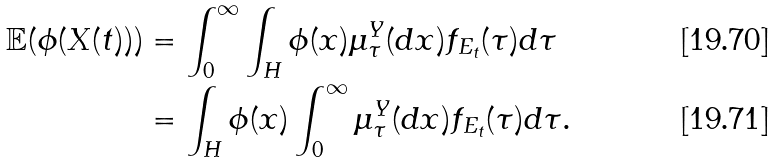Convert formula to latex. <formula><loc_0><loc_0><loc_500><loc_500>\mathbb { E } ( \phi ( X ( t ) ) ) & = \int _ { 0 } ^ { \infty } \int _ { H } \phi ( x ) \mu _ { \tau } ^ { Y } ( d x ) f _ { E _ { t } } ( \tau ) d \tau \\ & = \int _ { H } \phi ( x ) \int _ { 0 } ^ { \infty } \mu _ { \tau } ^ { Y } ( d x ) f _ { E _ { t } } ( \tau ) d \tau .</formula> 